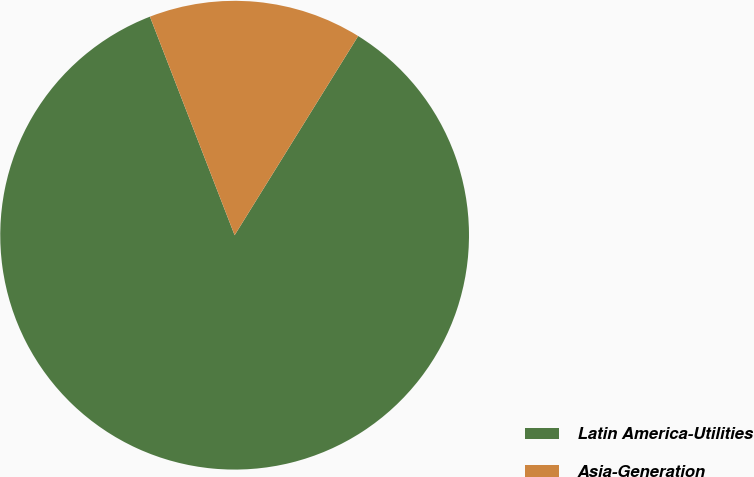Convert chart to OTSL. <chart><loc_0><loc_0><loc_500><loc_500><pie_chart><fcel>Latin America-Utilities<fcel>Asia-Generation<nl><fcel>85.28%<fcel>14.72%<nl></chart> 